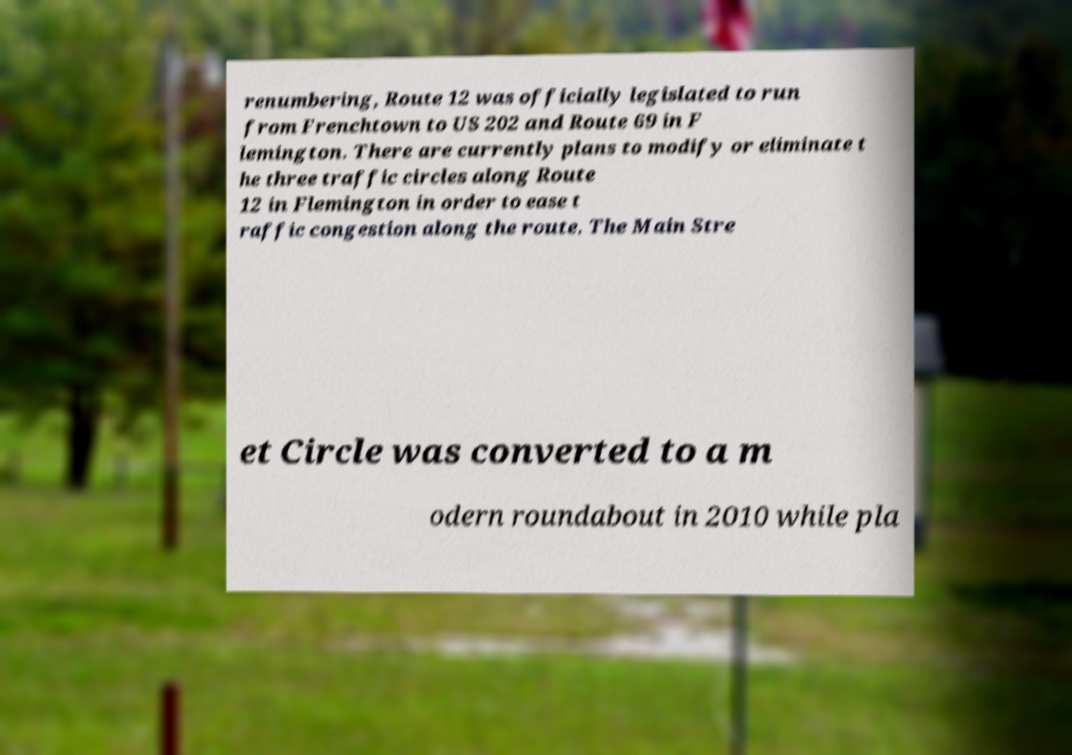Could you assist in decoding the text presented in this image and type it out clearly? renumbering, Route 12 was officially legislated to run from Frenchtown to US 202 and Route 69 in F lemington. There are currently plans to modify or eliminate t he three traffic circles along Route 12 in Flemington in order to ease t raffic congestion along the route. The Main Stre et Circle was converted to a m odern roundabout in 2010 while pla 